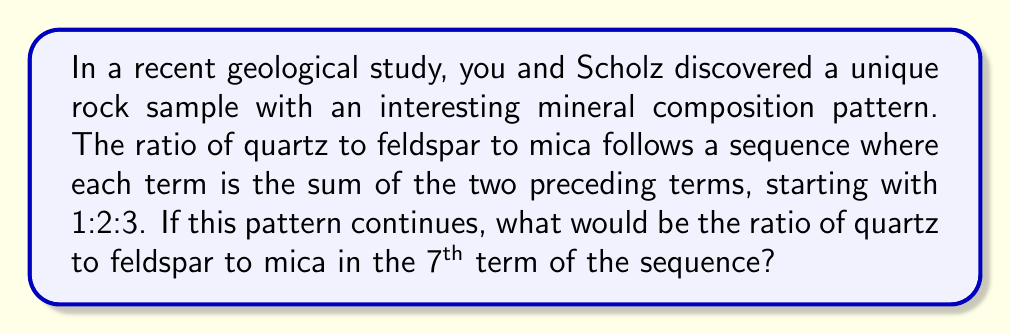What is the answer to this math problem? Let's approach this step-by-step:

1) First, let's write out the sequence for the first few terms:
   Term 1: 1 : 2 : 3
   Term 2: 2 : 3 : 5 (2+3 = 5)
   Term 3: 3 : 5 : 8 (3+5 = 8)
   Term 4: 5 : 8 : 13 (5+8 = 13)

2) We can see that this follows the Fibonacci sequence, where each number is the sum of the two preceding ones. Let's continue:
   Term 5: 8 : 13 : 21
   Term 6: 13 : 21 : 34
   Term 7: 21 : 34 : 55

3) We can verify the 7th term:
   $$21 + 34 = 55$$

4) Therefore, the ratio of quartz to feldspar to mica in the 7th term is 21 : 34 : 55.

5) This ratio can be expressed mathematically as:
   $$21 : 34 : 55$$

6) Note that this ratio cannot be further simplified as these numbers don't share a common factor greater than 1.
Answer: 21 : 34 : 55 